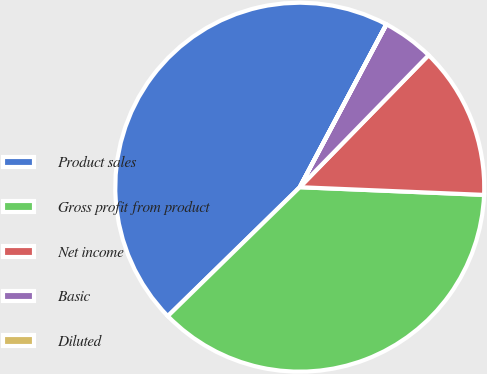Convert chart to OTSL. <chart><loc_0><loc_0><loc_500><loc_500><pie_chart><fcel>Product sales<fcel>Gross profit from product<fcel>Net income<fcel>Basic<fcel>Diluted<nl><fcel>45.09%<fcel>37.02%<fcel>13.36%<fcel>4.52%<fcel>0.01%<nl></chart> 